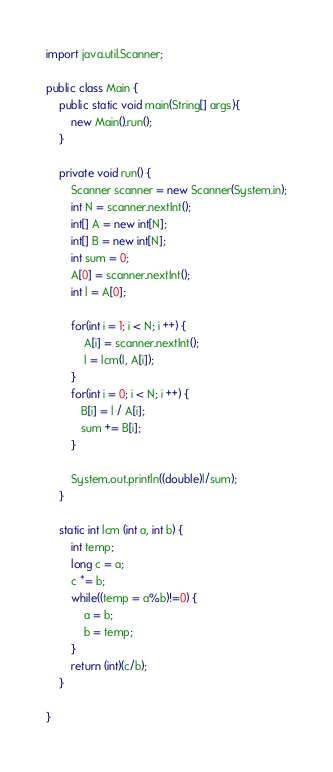Convert code to text. <code><loc_0><loc_0><loc_500><loc_500><_Java_>import java.util.Scanner;

public class Main {
    public static void main(String[] args){
        new Main().run();
    }

    private void run() {
        Scanner scanner = new Scanner(System.in);
        int N = scanner.nextInt();
        int[] A = new int[N];
        int[] B = new int[N];
        int sum = 0;
        A[0] = scanner.nextInt();
        int l = A[0];

        for(int i = 1; i < N; i ++) {
            A[i] = scanner.nextInt();
            l = lcm(l, A[i]);
        }
        for(int i = 0; i < N; i ++) {
           B[i] = l / A[i];
           sum += B[i];
        }

        System.out.println((double)l/sum);
    }

    static int lcm (int a, int b) {
        int temp;
        long c = a;
        c *= b;
        while((temp = a%b)!=0) {
            a = b;
            b = temp;
        }
        return (int)(c/b);
    }

}</code> 